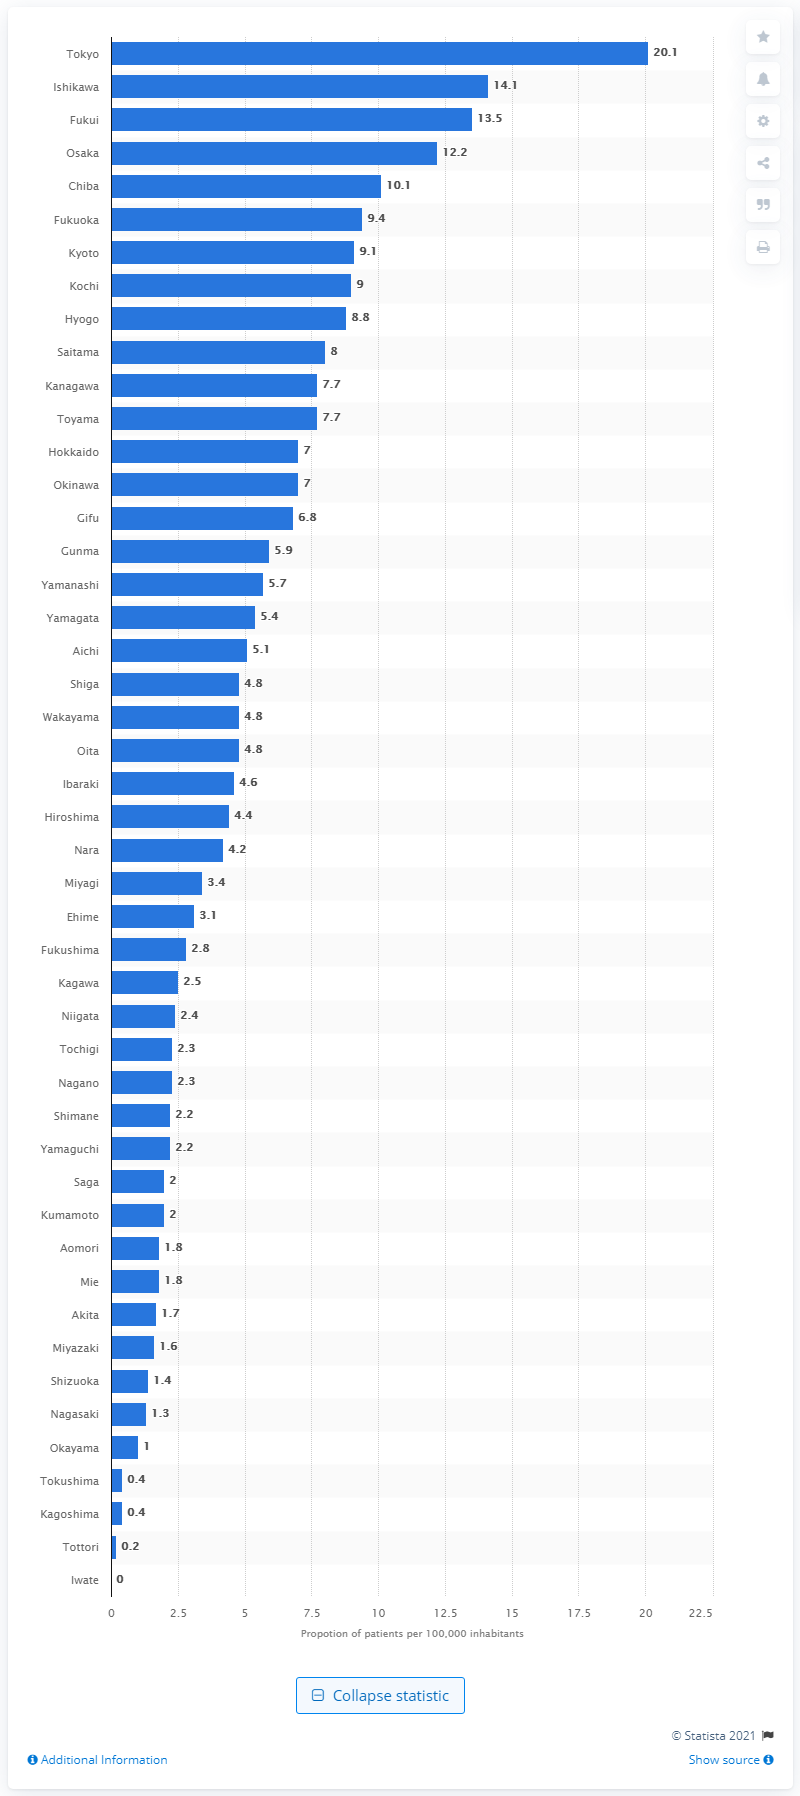Outline some significant characteristics in this image. As of April 17, 2020, there were 20.1 cases of COVID-19 per 100,000 inhabitants in Tokyo Prefecture. 